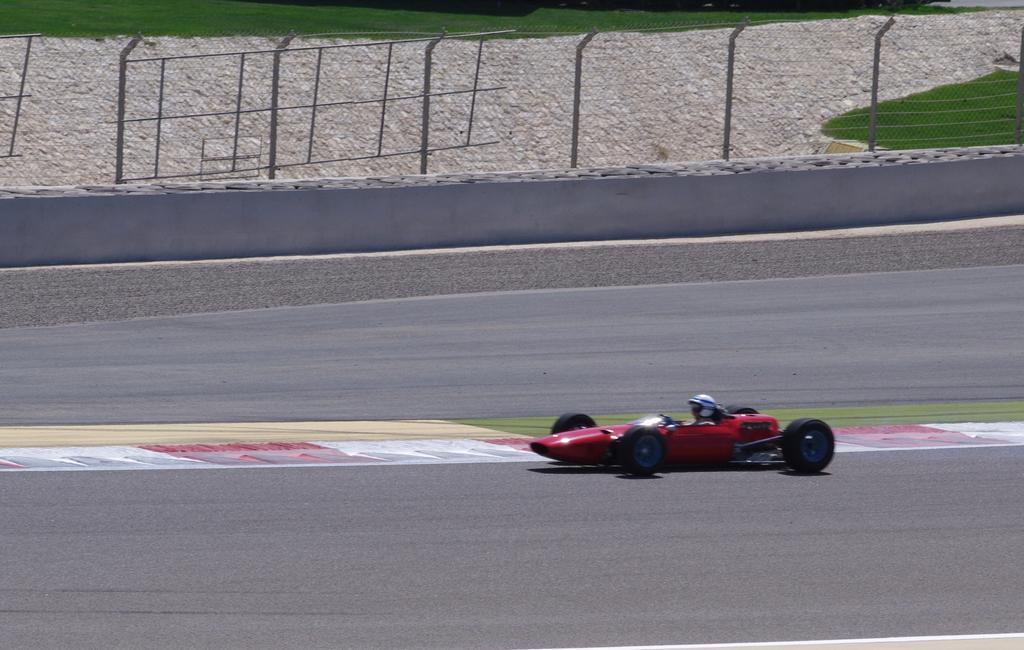How would you summarize this image in a sentence or two? In this picture we can see a person riding a red color car, in the background there is grass, we can see fencing in the middle, this person wore a helmet. 